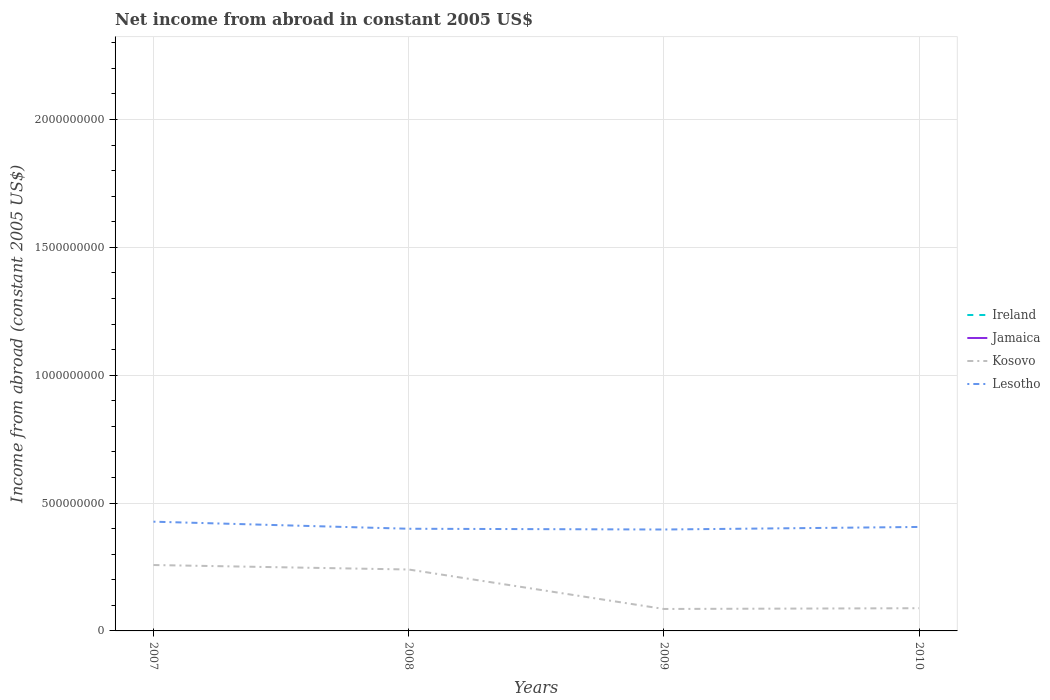How many different coloured lines are there?
Ensure brevity in your answer.  2. Does the line corresponding to Lesotho intersect with the line corresponding to Jamaica?
Your answer should be very brief. No. Is the number of lines equal to the number of legend labels?
Your response must be concise. No. Across all years, what is the maximum net income from abroad in Kosovo?
Provide a succinct answer. 8.59e+07. What is the total net income from abroad in Kosovo in the graph?
Offer a terse response. 1.54e+08. What is the difference between the highest and the second highest net income from abroad in Lesotho?
Your answer should be very brief. 3.06e+07. How many lines are there?
Provide a short and direct response. 2. How many years are there in the graph?
Keep it short and to the point. 4. What is the difference between two consecutive major ticks on the Y-axis?
Give a very brief answer. 5.00e+08. Are the values on the major ticks of Y-axis written in scientific E-notation?
Your response must be concise. No. Does the graph contain any zero values?
Your answer should be compact. Yes. Where does the legend appear in the graph?
Ensure brevity in your answer.  Center right. How are the legend labels stacked?
Your answer should be compact. Vertical. What is the title of the graph?
Your answer should be compact. Net income from abroad in constant 2005 US$. What is the label or title of the Y-axis?
Your response must be concise. Income from abroad (constant 2005 US$). What is the Income from abroad (constant 2005 US$) of Kosovo in 2007?
Your response must be concise. 2.58e+08. What is the Income from abroad (constant 2005 US$) in Lesotho in 2007?
Offer a very short reply. 4.27e+08. What is the Income from abroad (constant 2005 US$) in Jamaica in 2008?
Provide a succinct answer. 0. What is the Income from abroad (constant 2005 US$) of Kosovo in 2008?
Ensure brevity in your answer.  2.40e+08. What is the Income from abroad (constant 2005 US$) in Lesotho in 2008?
Provide a short and direct response. 4.00e+08. What is the Income from abroad (constant 2005 US$) of Ireland in 2009?
Your answer should be very brief. 0. What is the Income from abroad (constant 2005 US$) of Jamaica in 2009?
Ensure brevity in your answer.  0. What is the Income from abroad (constant 2005 US$) in Kosovo in 2009?
Provide a short and direct response. 8.59e+07. What is the Income from abroad (constant 2005 US$) of Lesotho in 2009?
Give a very brief answer. 3.97e+08. What is the Income from abroad (constant 2005 US$) in Jamaica in 2010?
Your answer should be very brief. 0. What is the Income from abroad (constant 2005 US$) of Kosovo in 2010?
Your response must be concise. 8.88e+07. What is the Income from abroad (constant 2005 US$) in Lesotho in 2010?
Give a very brief answer. 4.07e+08. Across all years, what is the maximum Income from abroad (constant 2005 US$) of Kosovo?
Give a very brief answer. 2.58e+08. Across all years, what is the maximum Income from abroad (constant 2005 US$) in Lesotho?
Your answer should be compact. 4.27e+08. Across all years, what is the minimum Income from abroad (constant 2005 US$) in Kosovo?
Your answer should be very brief. 8.59e+07. Across all years, what is the minimum Income from abroad (constant 2005 US$) of Lesotho?
Provide a succinct answer. 3.97e+08. What is the total Income from abroad (constant 2005 US$) of Ireland in the graph?
Offer a very short reply. 0. What is the total Income from abroad (constant 2005 US$) of Kosovo in the graph?
Make the answer very short. 6.73e+08. What is the total Income from abroad (constant 2005 US$) in Lesotho in the graph?
Offer a terse response. 1.63e+09. What is the difference between the Income from abroad (constant 2005 US$) of Kosovo in 2007 and that in 2008?
Your answer should be compact. 1.75e+07. What is the difference between the Income from abroad (constant 2005 US$) in Lesotho in 2007 and that in 2008?
Give a very brief answer. 2.77e+07. What is the difference between the Income from abroad (constant 2005 US$) of Kosovo in 2007 and that in 2009?
Keep it short and to the point. 1.72e+08. What is the difference between the Income from abroad (constant 2005 US$) of Lesotho in 2007 and that in 2009?
Offer a very short reply. 3.06e+07. What is the difference between the Income from abroad (constant 2005 US$) in Kosovo in 2007 and that in 2010?
Make the answer very short. 1.69e+08. What is the difference between the Income from abroad (constant 2005 US$) in Lesotho in 2007 and that in 2010?
Your response must be concise. 2.06e+07. What is the difference between the Income from abroad (constant 2005 US$) of Kosovo in 2008 and that in 2009?
Offer a very short reply. 1.54e+08. What is the difference between the Income from abroad (constant 2005 US$) of Lesotho in 2008 and that in 2009?
Ensure brevity in your answer.  2.96e+06. What is the difference between the Income from abroad (constant 2005 US$) of Kosovo in 2008 and that in 2010?
Ensure brevity in your answer.  1.51e+08. What is the difference between the Income from abroad (constant 2005 US$) in Lesotho in 2008 and that in 2010?
Ensure brevity in your answer.  -7.02e+06. What is the difference between the Income from abroad (constant 2005 US$) of Kosovo in 2009 and that in 2010?
Make the answer very short. -2.94e+06. What is the difference between the Income from abroad (constant 2005 US$) in Lesotho in 2009 and that in 2010?
Offer a very short reply. -9.99e+06. What is the difference between the Income from abroad (constant 2005 US$) in Kosovo in 2007 and the Income from abroad (constant 2005 US$) in Lesotho in 2008?
Keep it short and to the point. -1.42e+08. What is the difference between the Income from abroad (constant 2005 US$) of Kosovo in 2007 and the Income from abroad (constant 2005 US$) of Lesotho in 2009?
Provide a short and direct response. -1.39e+08. What is the difference between the Income from abroad (constant 2005 US$) of Kosovo in 2007 and the Income from abroad (constant 2005 US$) of Lesotho in 2010?
Provide a short and direct response. -1.49e+08. What is the difference between the Income from abroad (constant 2005 US$) of Kosovo in 2008 and the Income from abroad (constant 2005 US$) of Lesotho in 2009?
Keep it short and to the point. -1.56e+08. What is the difference between the Income from abroad (constant 2005 US$) of Kosovo in 2008 and the Income from abroad (constant 2005 US$) of Lesotho in 2010?
Make the answer very short. -1.66e+08. What is the difference between the Income from abroad (constant 2005 US$) in Kosovo in 2009 and the Income from abroad (constant 2005 US$) in Lesotho in 2010?
Give a very brief answer. -3.21e+08. What is the average Income from abroad (constant 2005 US$) in Kosovo per year?
Make the answer very short. 1.68e+08. What is the average Income from abroad (constant 2005 US$) of Lesotho per year?
Provide a succinct answer. 4.08e+08. In the year 2007, what is the difference between the Income from abroad (constant 2005 US$) of Kosovo and Income from abroad (constant 2005 US$) of Lesotho?
Offer a terse response. -1.70e+08. In the year 2008, what is the difference between the Income from abroad (constant 2005 US$) of Kosovo and Income from abroad (constant 2005 US$) of Lesotho?
Keep it short and to the point. -1.59e+08. In the year 2009, what is the difference between the Income from abroad (constant 2005 US$) in Kosovo and Income from abroad (constant 2005 US$) in Lesotho?
Offer a very short reply. -3.11e+08. In the year 2010, what is the difference between the Income from abroad (constant 2005 US$) in Kosovo and Income from abroad (constant 2005 US$) in Lesotho?
Your answer should be very brief. -3.18e+08. What is the ratio of the Income from abroad (constant 2005 US$) in Kosovo in 2007 to that in 2008?
Ensure brevity in your answer.  1.07. What is the ratio of the Income from abroad (constant 2005 US$) of Lesotho in 2007 to that in 2008?
Keep it short and to the point. 1.07. What is the ratio of the Income from abroad (constant 2005 US$) in Kosovo in 2007 to that in 2009?
Your answer should be very brief. 3. What is the ratio of the Income from abroad (constant 2005 US$) in Lesotho in 2007 to that in 2009?
Your response must be concise. 1.08. What is the ratio of the Income from abroad (constant 2005 US$) in Kosovo in 2007 to that in 2010?
Keep it short and to the point. 2.9. What is the ratio of the Income from abroad (constant 2005 US$) in Lesotho in 2007 to that in 2010?
Keep it short and to the point. 1.05. What is the ratio of the Income from abroad (constant 2005 US$) of Kosovo in 2008 to that in 2009?
Provide a short and direct response. 2.8. What is the ratio of the Income from abroad (constant 2005 US$) of Lesotho in 2008 to that in 2009?
Give a very brief answer. 1.01. What is the ratio of the Income from abroad (constant 2005 US$) in Kosovo in 2008 to that in 2010?
Your answer should be very brief. 2.71. What is the ratio of the Income from abroad (constant 2005 US$) in Lesotho in 2008 to that in 2010?
Provide a succinct answer. 0.98. What is the ratio of the Income from abroad (constant 2005 US$) of Kosovo in 2009 to that in 2010?
Keep it short and to the point. 0.97. What is the ratio of the Income from abroad (constant 2005 US$) in Lesotho in 2009 to that in 2010?
Give a very brief answer. 0.98. What is the difference between the highest and the second highest Income from abroad (constant 2005 US$) of Kosovo?
Offer a terse response. 1.75e+07. What is the difference between the highest and the second highest Income from abroad (constant 2005 US$) in Lesotho?
Offer a very short reply. 2.06e+07. What is the difference between the highest and the lowest Income from abroad (constant 2005 US$) in Kosovo?
Offer a terse response. 1.72e+08. What is the difference between the highest and the lowest Income from abroad (constant 2005 US$) in Lesotho?
Keep it short and to the point. 3.06e+07. 